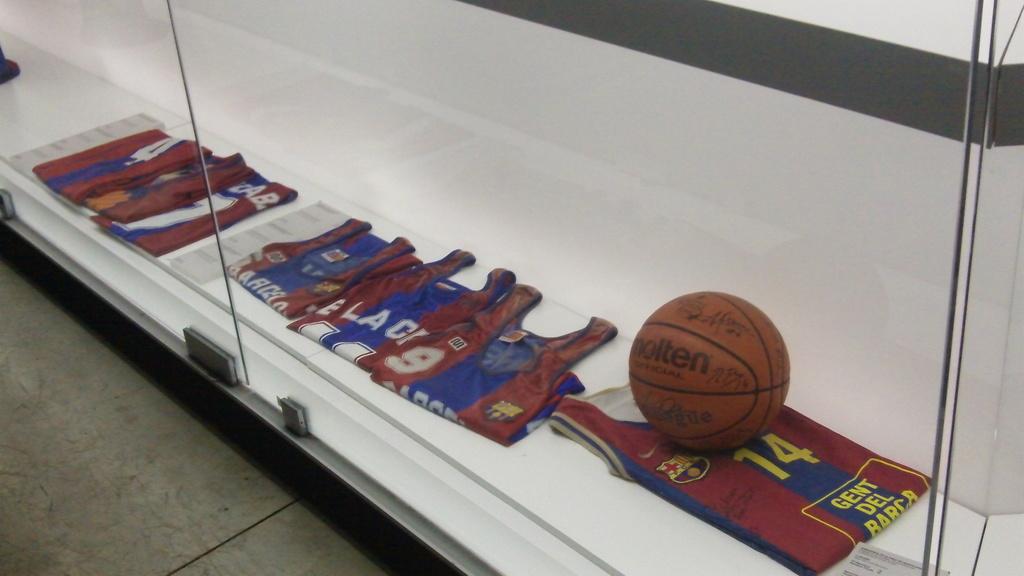What is the number on the jersey?
Provide a succinct answer. 14. 